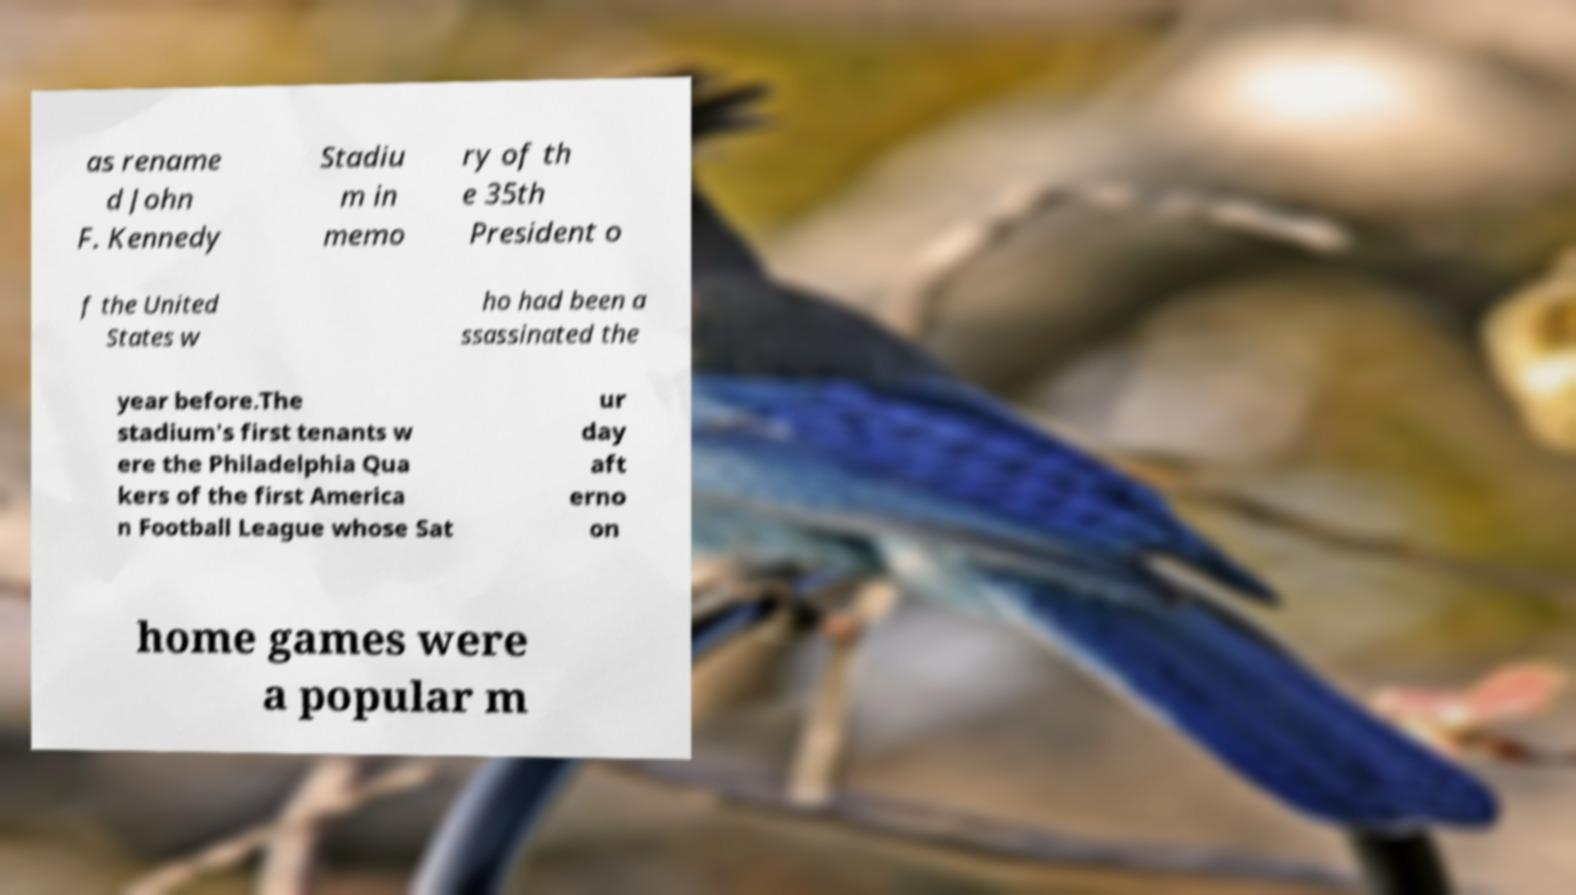There's text embedded in this image that I need extracted. Can you transcribe it verbatim? as rename d John F. Kennedy Stadiu m in memo ry of th e 35th President o f the United States w ho had been a ssassinated the year before.The stadium's first tenants w ere the Philadelphia Qua kers of the first America n Football League whose Sat ur day aft erno on home games were a popular m 